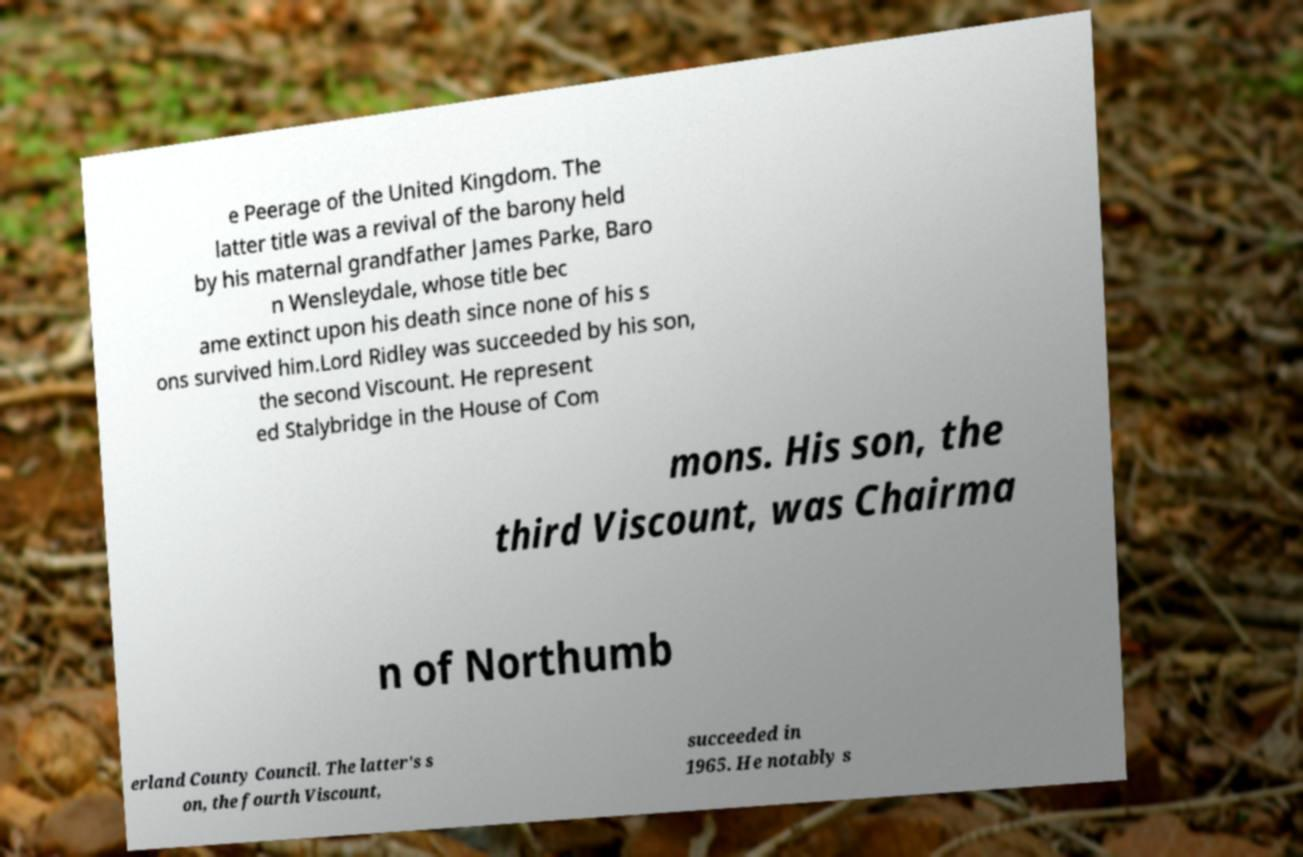Please read and relay the text visible in this image. What does it say? e Peerage of the United Kingdom. The latter title was a revival of the barony held by his maternal grandfather James Parke, Baro n Wensleydale, whose title bec ame extinct upon his death since none of his s ons survived him.Lord Ridley was succeeded by his son, the second Viscount. He represent ed Stalybridge in the House of Com mons. His son, the third Viscount, was Chairma n of Northumb erland County Council. The latter's s on, the fourth Viscount, succeeded in 1965. He notably s 